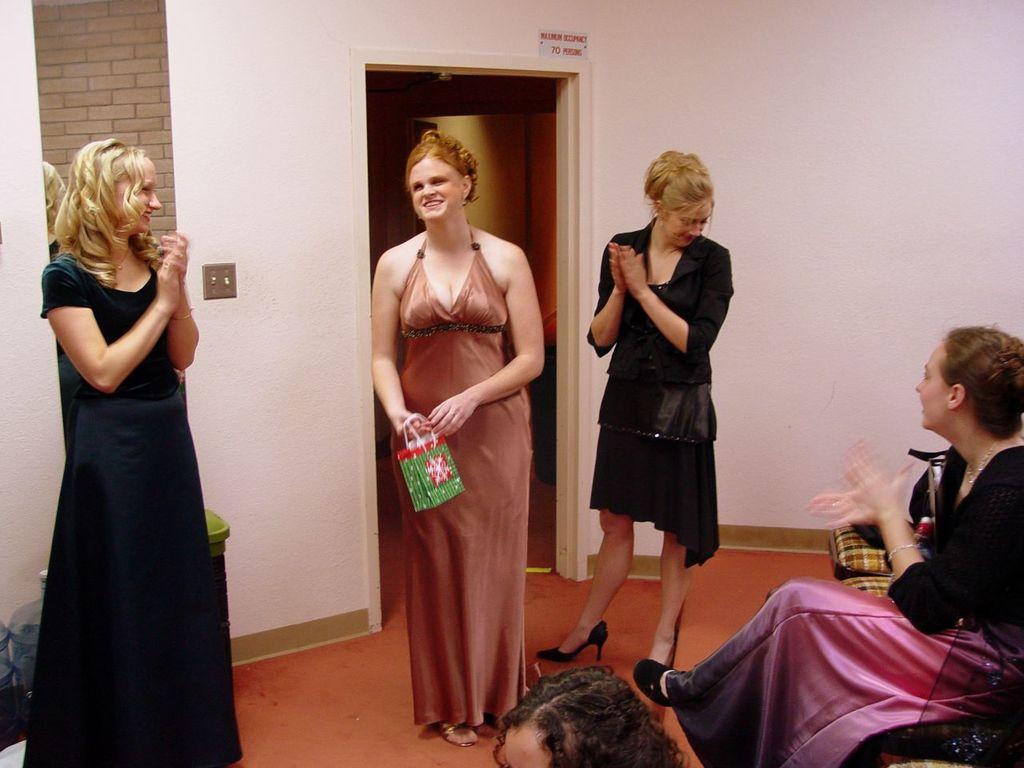Describe this image in one or two sentences. There are three women in different color dresses, standing on the orange color floor, near person who is sitting on a chair. In the background, there is a mirror on the white wall, near a door. 